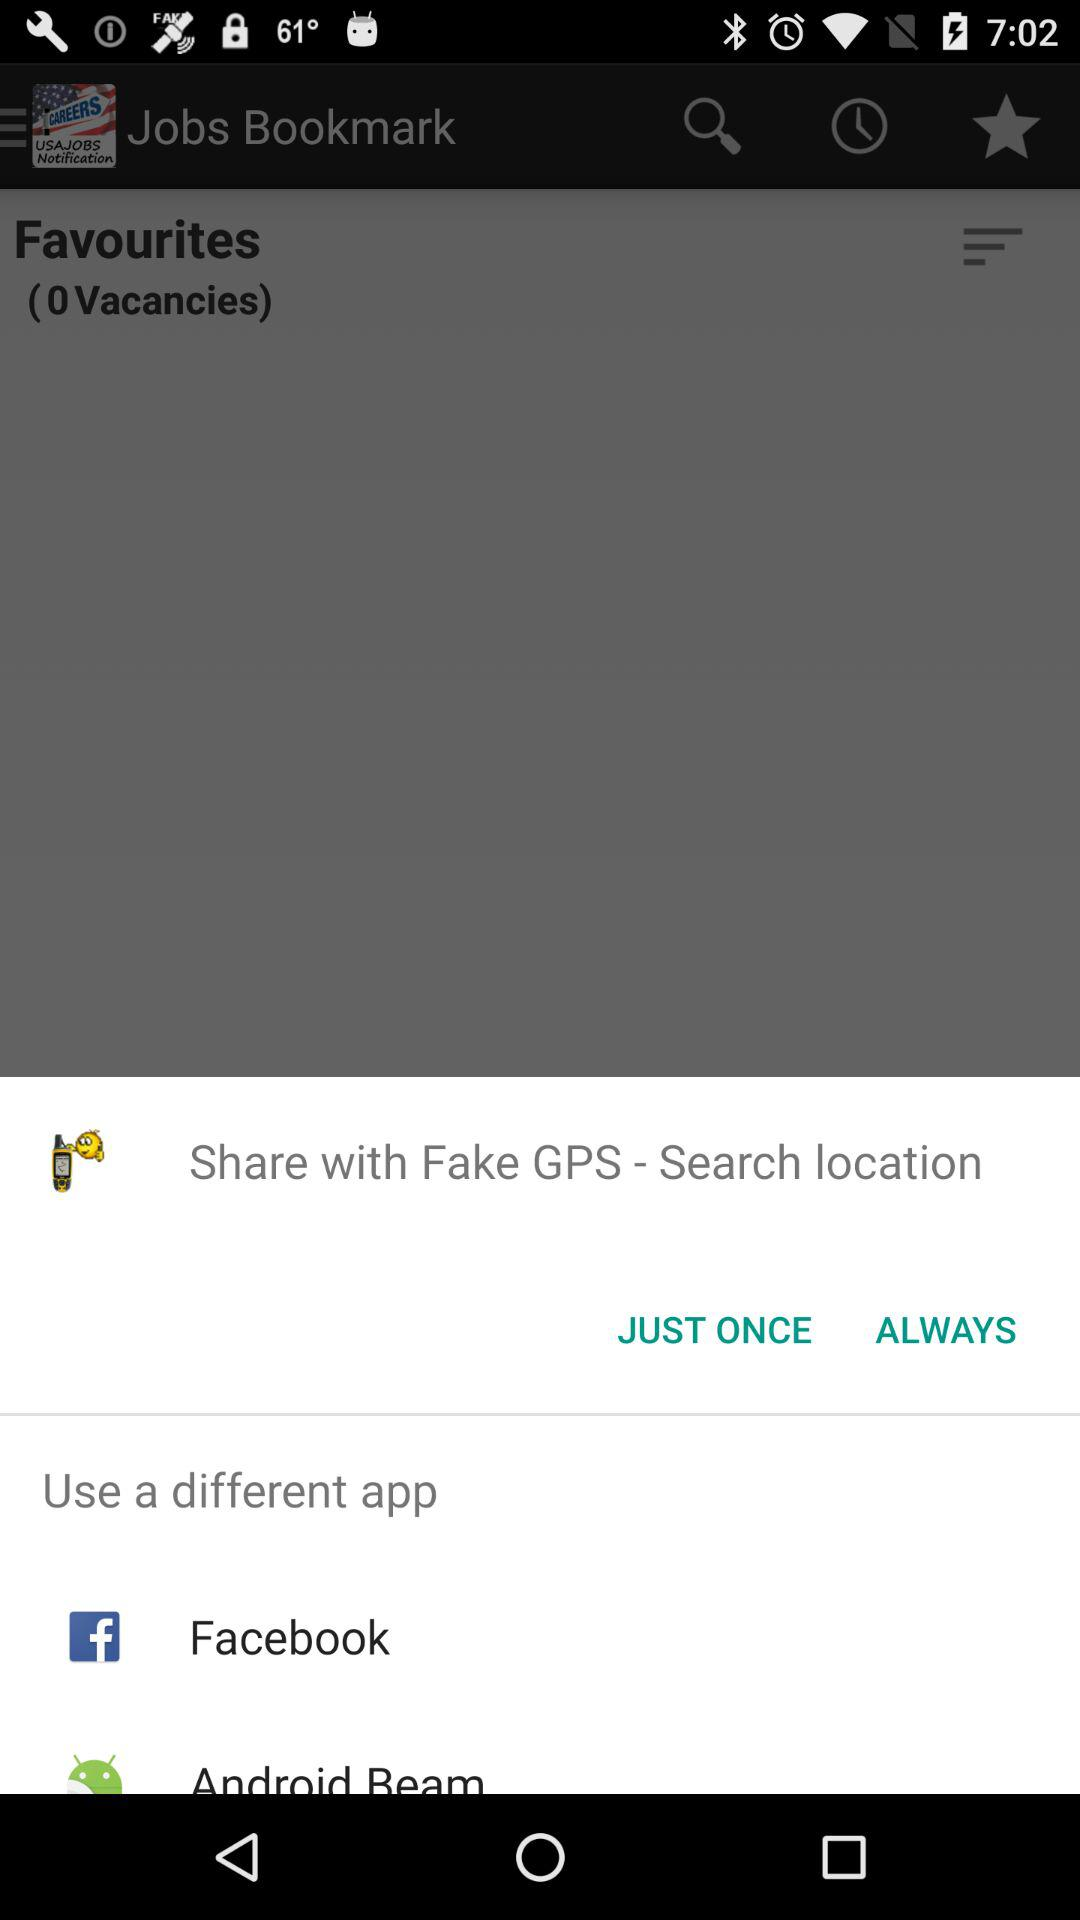What is the total number of vacancies? The total number of vacancies is 0. 